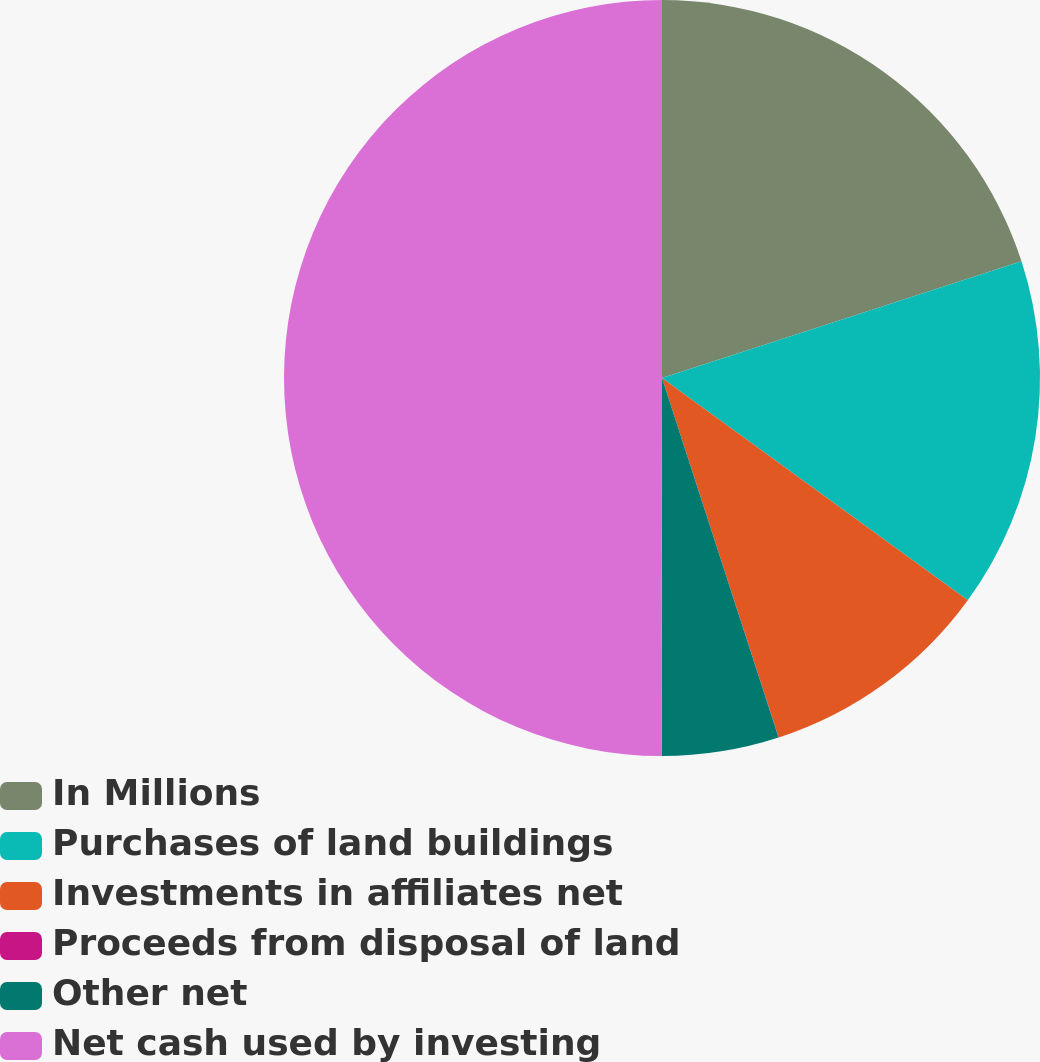Convert chart. <chart><loc_0><loc_0><loc_500><loc_500><pie_chart><fcel>In Millions<fcel>Purchases of land buildings<fcel>Investments in affiliates net<fcel>Proceeds from disposal of land<fcel>Other net<fcel>Net cash used by investing<nl><fcel>20.0%<fcel>15.0%<fcel>10.0%<fcel>0.01%<fcel>5.01%<fcel>49.98%<nl></chart> 